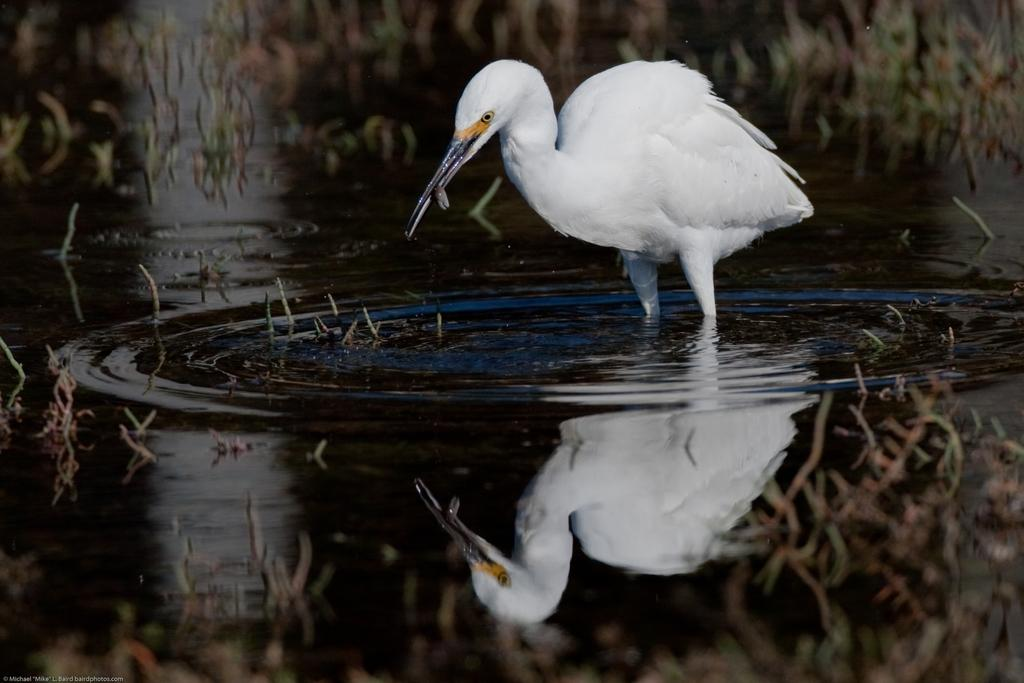What is the main subject in the center of the image? There is a crane in the center of the image. What can be seen at the bottom of the image? There is water visible at the bottom of the image. How many snakes are slithering around the crane in the image? There are no snakes present in the image. What type of magic is being performed by the crane in the image? There is no magic being performed by the crane in the image; it is a stationary object. 